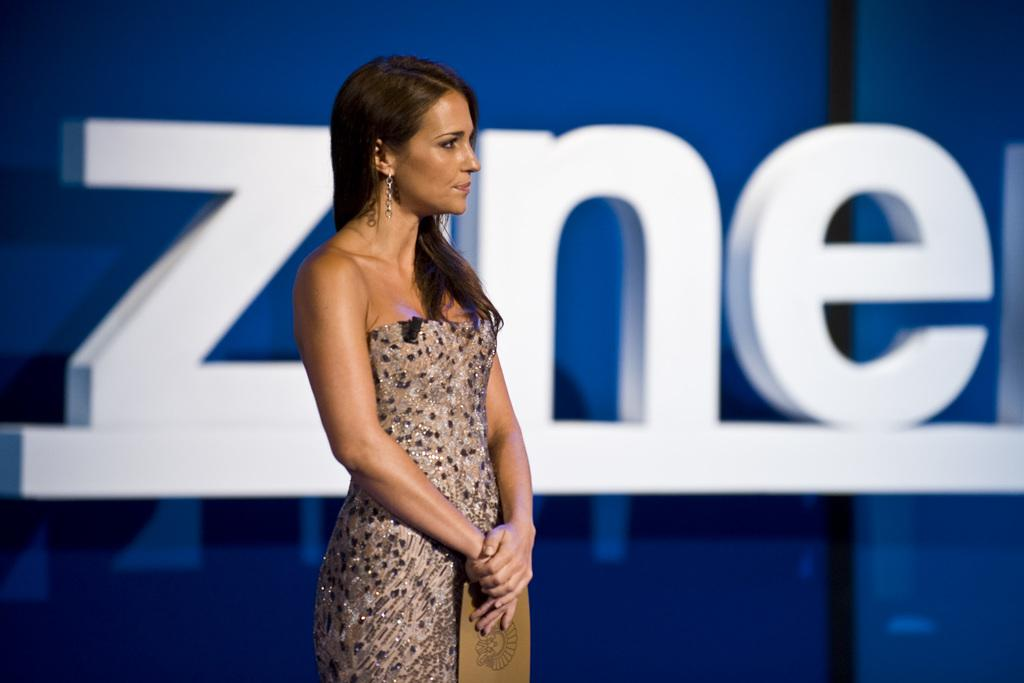Who is present in the image? There is a woman in the picture. What is the woman wearing? The woman is wearing a cream-colored dress. What is the woman holding in the image? The woman is holding a card. What color is the banner in the background of the picture? There is a blue color banner in the background of the picture. What type of can is visible in the image? There is no can present in the image. Is there a cushion on the floor in the image? There is no mention of a cushion or floor in the provided facts, so it cannot be determined from the image. 